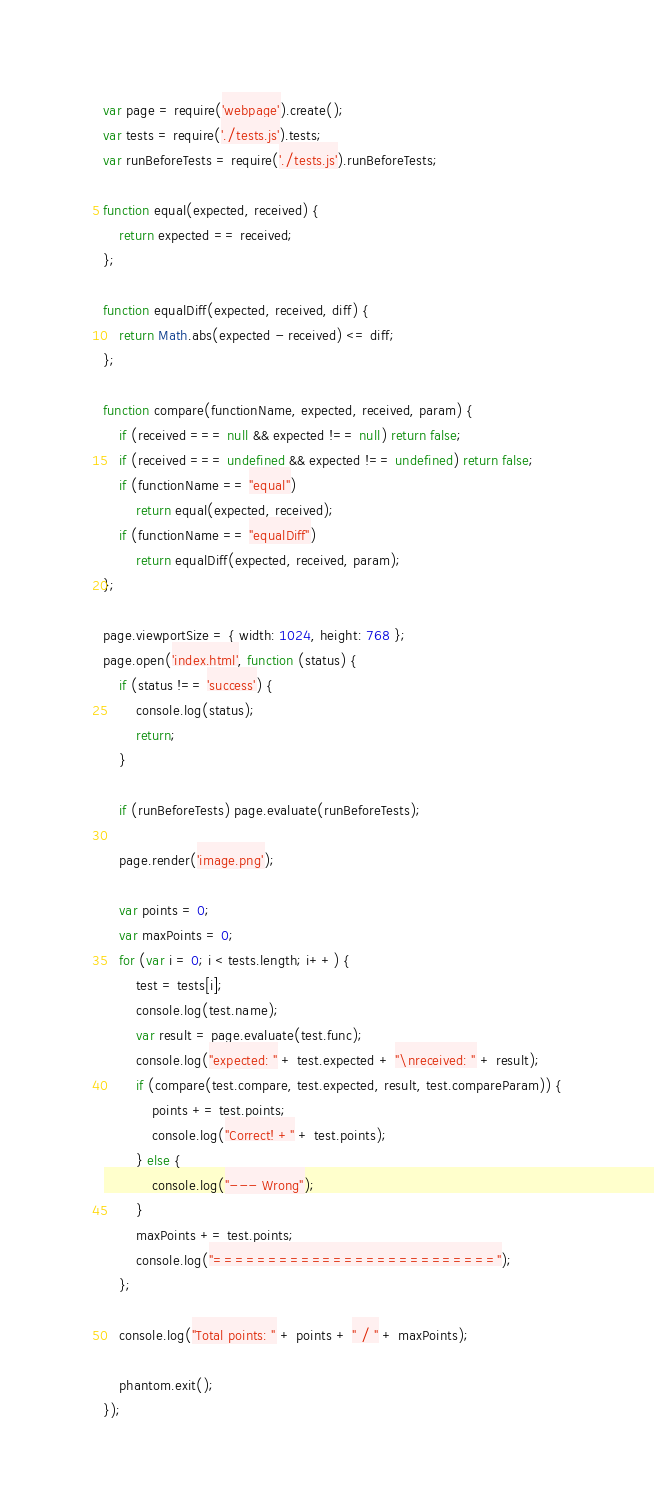<code> <loc_0><loc_0><loc_500><loc_500><_JavaScript_>var page = require('webpage').create();
var tests = require('./tests.js').tests;
var runBeforeTests = require('./tests.js').runBeforeTests;

function equal(expected, received) {
    return expected == received;
};

function equalDiff(expected, received, diff) {
    return Math.abs(expected - received) <= diff;
};

function compare(functionName, expected, received, param) {
    if (received === null && expected !== null) return false;
    if (received === undefined && expected !== undefined) return false;
    if (functionName == "equal")
        return equal(expected, received);
    if (functionName == "equalDiff")
        return equalDiff(expected, received, param);
};

page.viewportSize = { width: 1024, height: 768 };
page.open('index.html', function (status) {
    if (status !== 'success') {
        console.log(status);
        return;
    }

    if (runBeforeTests) page.evaluate(runBeforeTests);

    page.render('image.png');

    var points = 0;
    var maxPoints = 0;
    for (var i = 0; i < tests.length; i++) {
        test = tests[i];
        console.log(test.name);
        var result = page.evaluate(test.func);
        console.log("expected: " + test.expected + "\nreceived: " + result);
        if (compare(test.compare, test.expected, result, test.compareParam)) {
            points += test.points;
            console.log("Correct! +" + test.points);
        } else {
            console.log("--- Wrong");
        }
        maxPoints += test.points;
        console.log("==========================");
    };

    console.log("Total points: " + points + " / " + maxPoints);

    phantom.exit();
});
</code> 